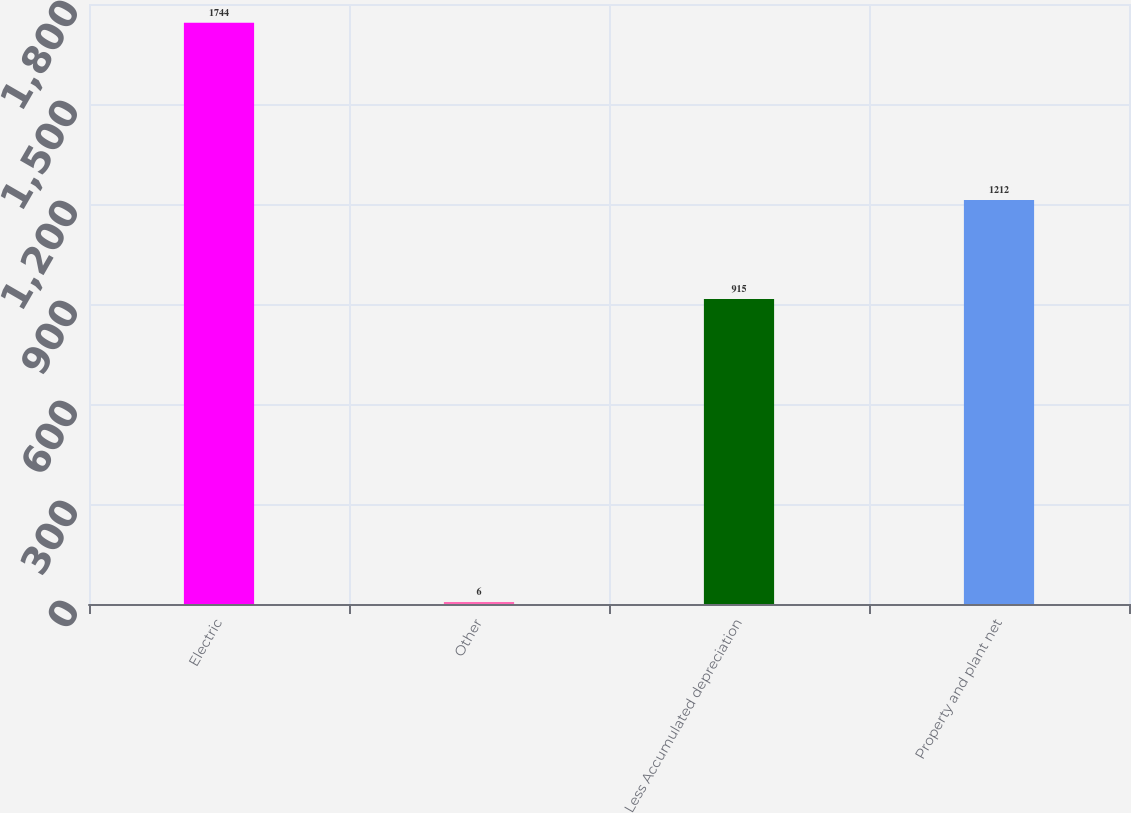Convert chart. <chart><loc_0><loc_0><loc_500><loc_500><bar_chart><fcel>Electric<fcel>Other<fcel>Less Accumulated depreciation<fcel>Property and plant net<nl><fcel>1744<fcel>6<fcel>915<fcel>1212<nl></chart> 